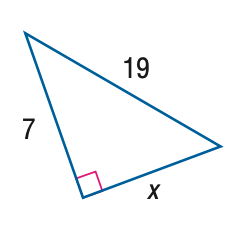Question: Find x.
Choices:
A. 7
B. 2 \sqrt { 78 }
C. 19
D. \sqrt { 410 }
Answer with the letter. Answer: B 